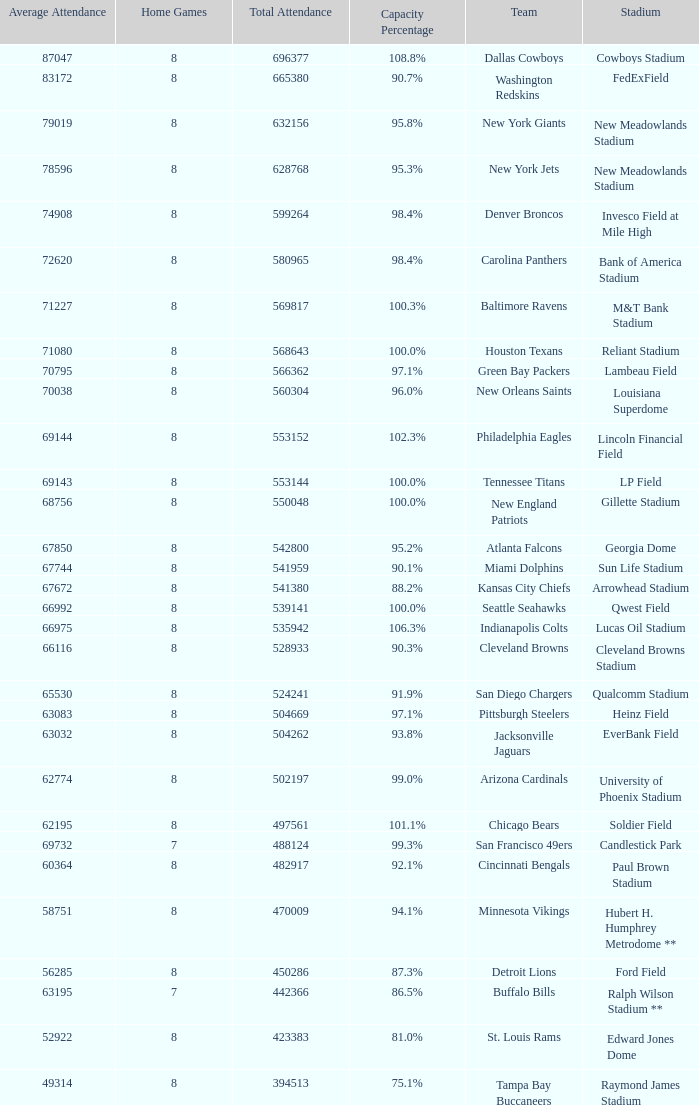What was the capacity for the Denver Broncos? 98.4%. 